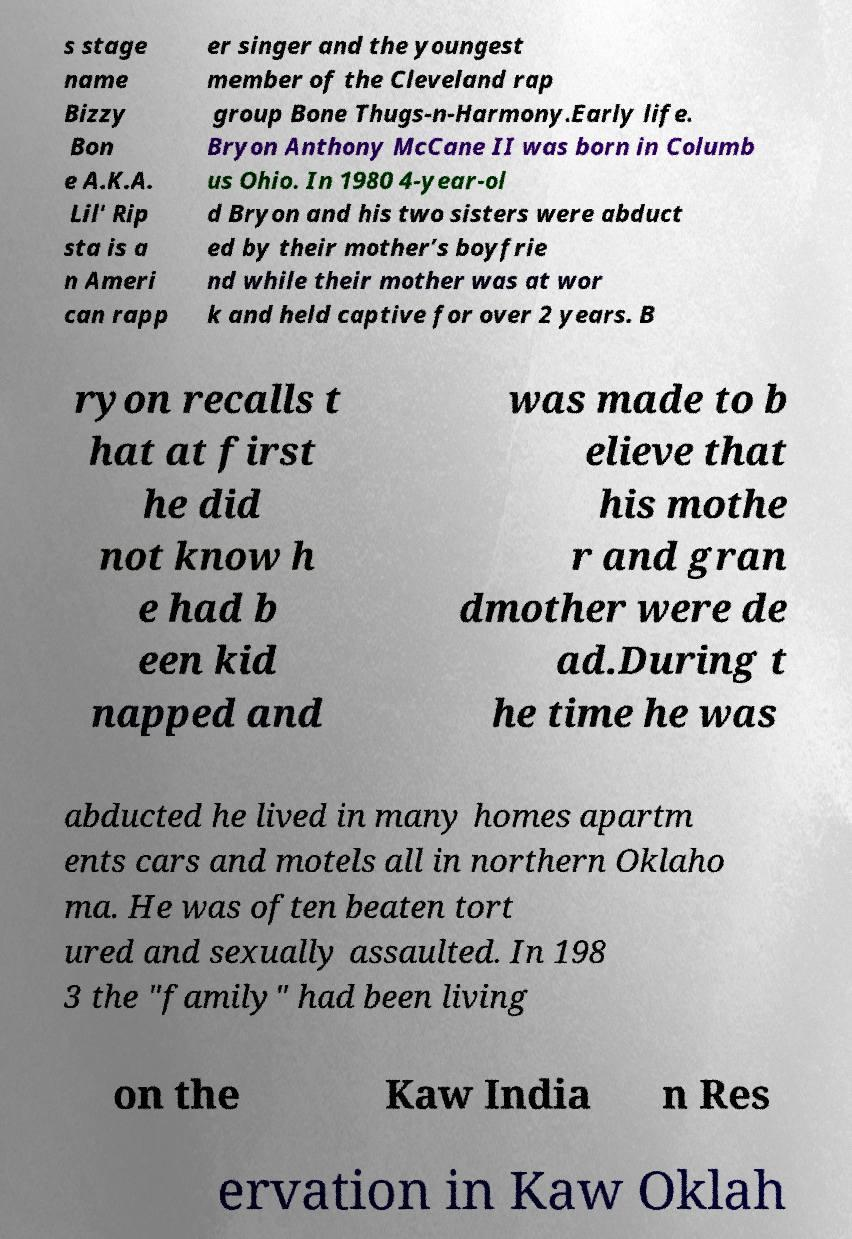Could you extract and type out the text from this image? s stage name Bizzy Bon e A.K.A. Lil' Rip sta is a n Ameri can rapp er singer and the youngest member of the Cleveland rap group Bone Thugs-n-Harmony.Early life. Bryon Anthony McCane II was born in Columb us Ohio. In 1980 4-year-ol d Bryon and his two sisters were abduct ed by their mother’s boyfrie nd while their mother was at wor k and held captive for over 2 years. B ryon recalls t hat at first he did not know h e had b een kid napped and was made to b elieve that his mothe r and gran dmother were de ad.During t he time he was abducted he lived in many homes apartm ents cars and motels all in northern Oklaho ma. He was often beaten tort ured and sexually assaulted. In 198 3 the "family" had been living on the Kaw India n Res ervation in Kaw Oklah 